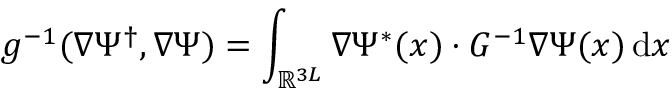<formula> <loc_0><loc_0><loc_500><loc_500>g ^ { - 1 } ( \nabla \Psi ^ { \dagger } , \nabla \Psi ) = \int _ { \mathbb { R } ^ { 3 L } } \nabla \Psi ^ { * } ( x ) \cdot G ^ { - 1 } \nabla \Psi ( x ) \, { d } x</formula> 